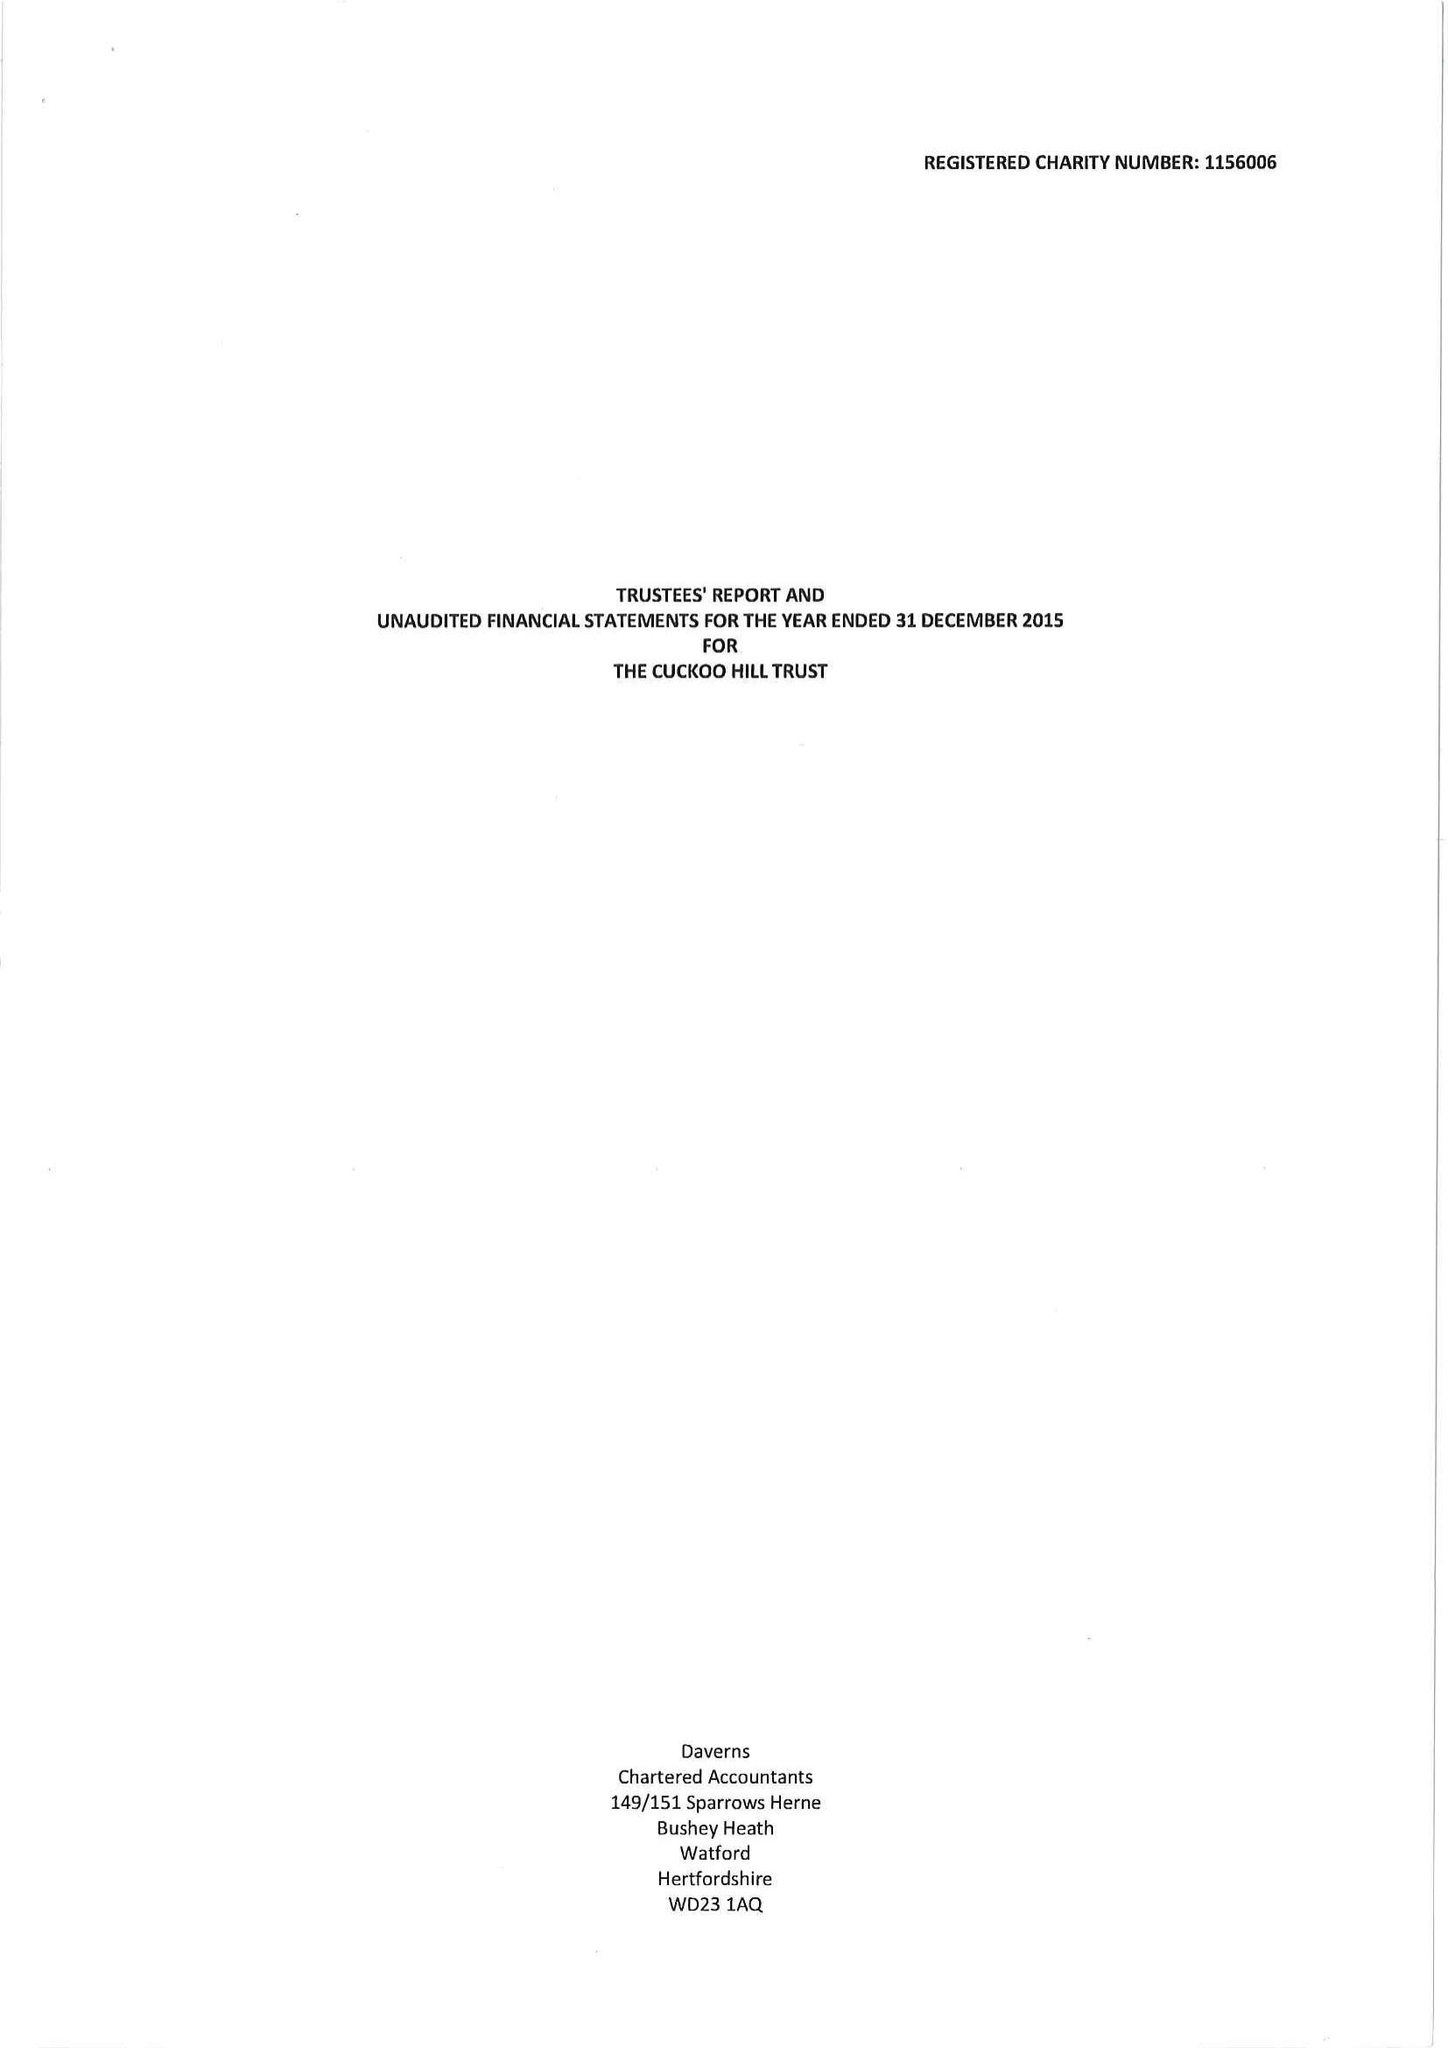What is the value for the address__street_line?
Answer the question using a single word or phrase. CUCKOO HILL 